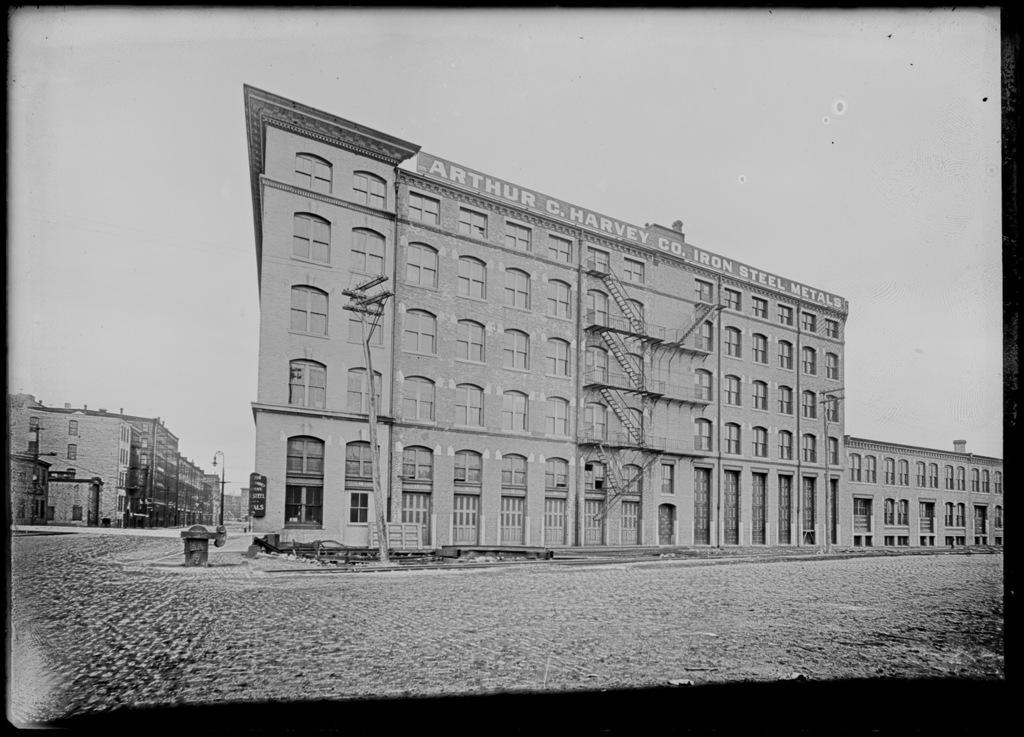What type of picture is in the image? The image contains a black and white picture. What structures can be seen in the picture? There are buildings in the image. What type of pole is present in the image? There is a light pole and a current pole in the image. What is on the ground in the image? There is an object on the ground in the image. What is visible at the top of the image? The sky is visible at the top of the image. What day of the week is depicted in the image? The image does not depict a day of the week; it is a black and white picture of buildings, poles, and an object on the ground. Is there any motion or movement happening in the image? The image does not show any motion or movement; it is a still picture. 